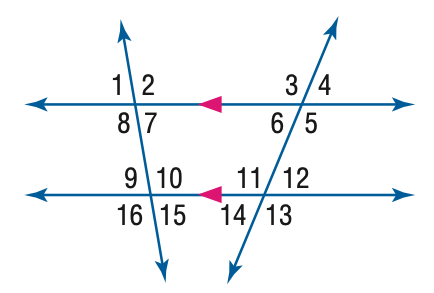Can you determine the measure of angle 14 from the given image? Certainly! In the image, angle 14 and angle 12 form another pair of vertical angles, which means they are congruent, and their measures are the same. Since m \angle 12 is given as 42 degrees, m \angle 14 would also be 42 degrees. 